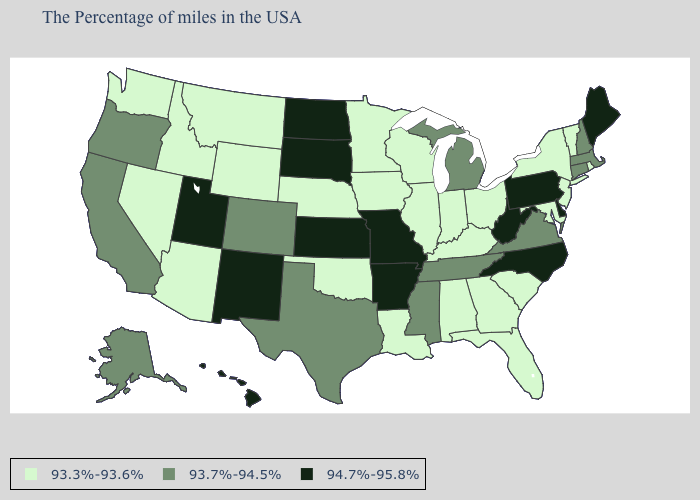What is the value of North Carolina?
Be succinct. 94.7%-95.8%. What is the highest value in the West ?
Give a very brief answer. 94.7%-95.8%. Name the states that have a value in the range 93.3%-93.6%?
Be succinct. Rhode Island, Vermont, New York, New Jersey, Maryland, South Carolina, Ohio, Florida, Georgia, Kentucky, Indiana, Alabama, Wisconsin, Illinois, Louisiana, Minnesota, Iowa, Nebraska, Oklahoma, Wyoming, Montana, Arizona, Idaho, Nevada, Washington. What is the highest value in the USA?
Be succinct. 94.7%-95.8%. Name the states that have a value in the range 93.7%-94.5%?
Answer briefly. Massachusetts, New Hampshire, Connecticut, Virginia, Michigan, Tennessee, Mississippi, Texas, Colorado, California, Oregon, Alaska. Name the states that have a value in the range 93.3%-93.6%?
Give a very brief answer. Rhode Island, Vermont, New York, New Jersey, Maryland, South Carolina, Ohio, Florida, Georgia, Kentucky, Indiana, Alabama, Wisconsin, Illinois, Louisiana, Minnesota, Iowa, Nebraska, Oklahoma, Wyoming, Montana, Arizona, Idaho, Nevada, Washington. Name the states that have a value in the range 93.7%-94.5%?
Write a very short answer. Massachusetts, New Hampshire, Connecticut, Virginia, Michigan, Tennessee, Mississippi, Texas, Colorado, California, Oregon, Alaska. Among the states that border Rhode Island , which have the highest value?
Concise answer only. Massachusetts, Connecticut. Does Florida have the highest value in the South?
Give a very brief answer. No. Does New York have a lower value than Iowa?
Concise answer only. No. What is the value of Illinois?
Be succinct. 93.3%-93.6%. What is the lowest value in the USA?
Write a very short answer. 93.3%-93.6%. Name the states that have a value in the range 93.7%-94.5%?
Answer briefly. Massachusetts, New Hampshire, Connecticut, Virginia, Michigan, Tennessee, Mississippi, Texas, Colorado, California, Oregon, Alaska. Does the first symbol in the legend represent the smallest category?
Give a very brief answer. Yes. 